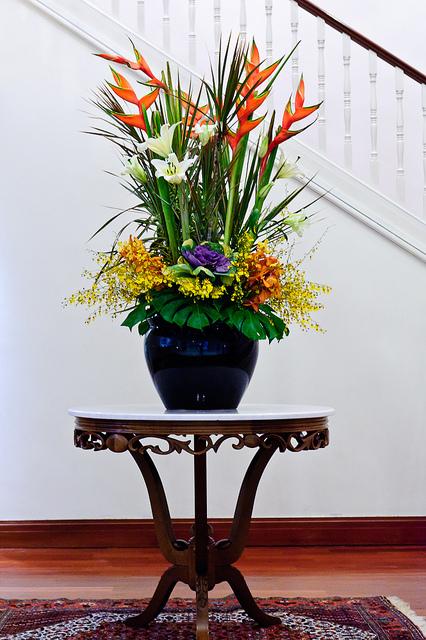What color are the flowers?
Concise answer only. Orange, white, yellow and purple. What color is the vase?
Concise answer only. Blue. Is there a staircase in the picture?
Answer briefly. Yes. 